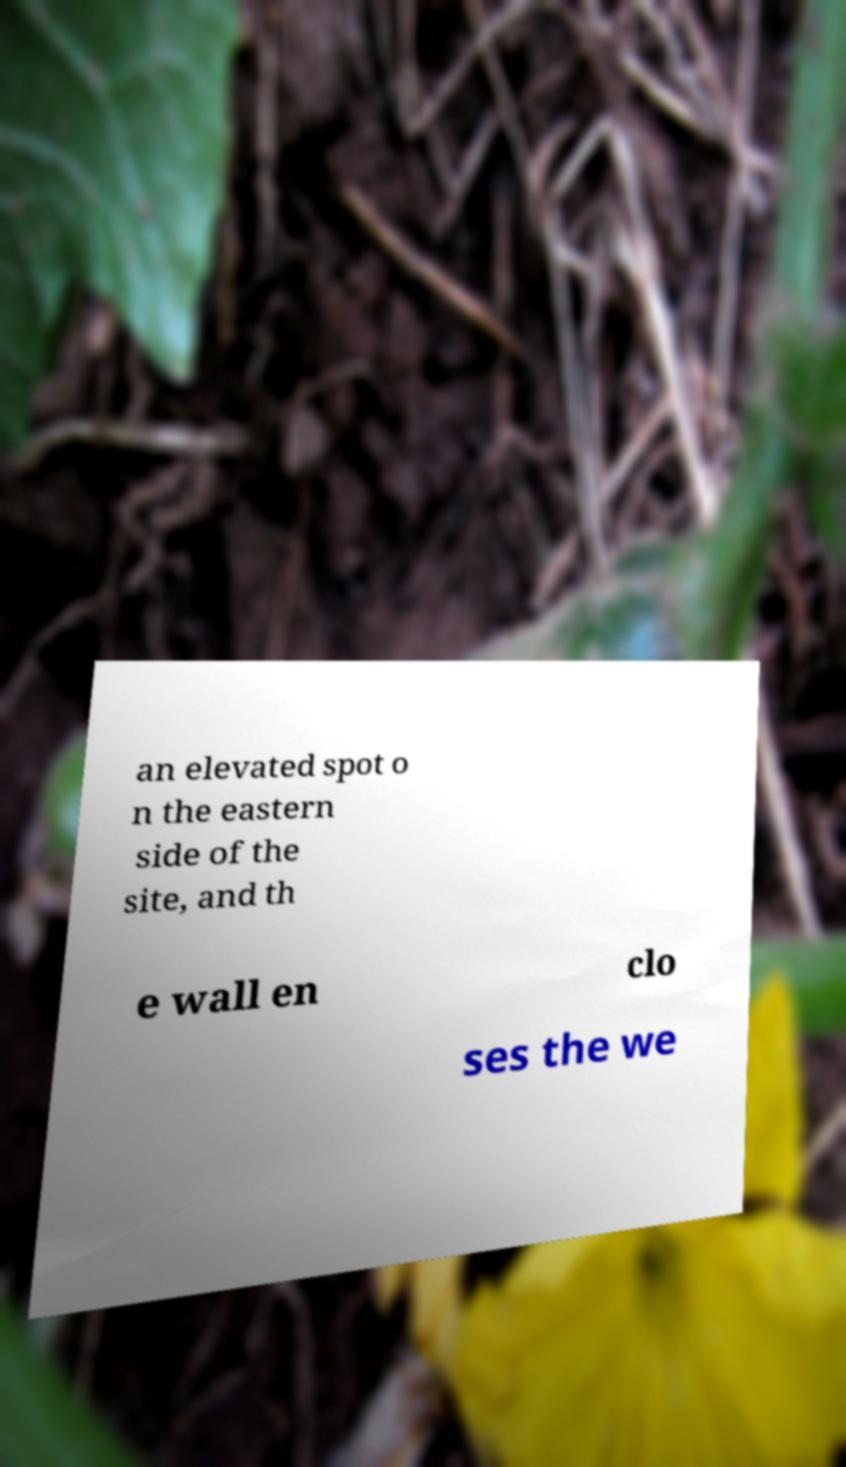For documentation purposes, I need the text within this image transcribed. Could you provide that? an elevated spot o n the eastern side of the site, and th e wall en clo ses the we 